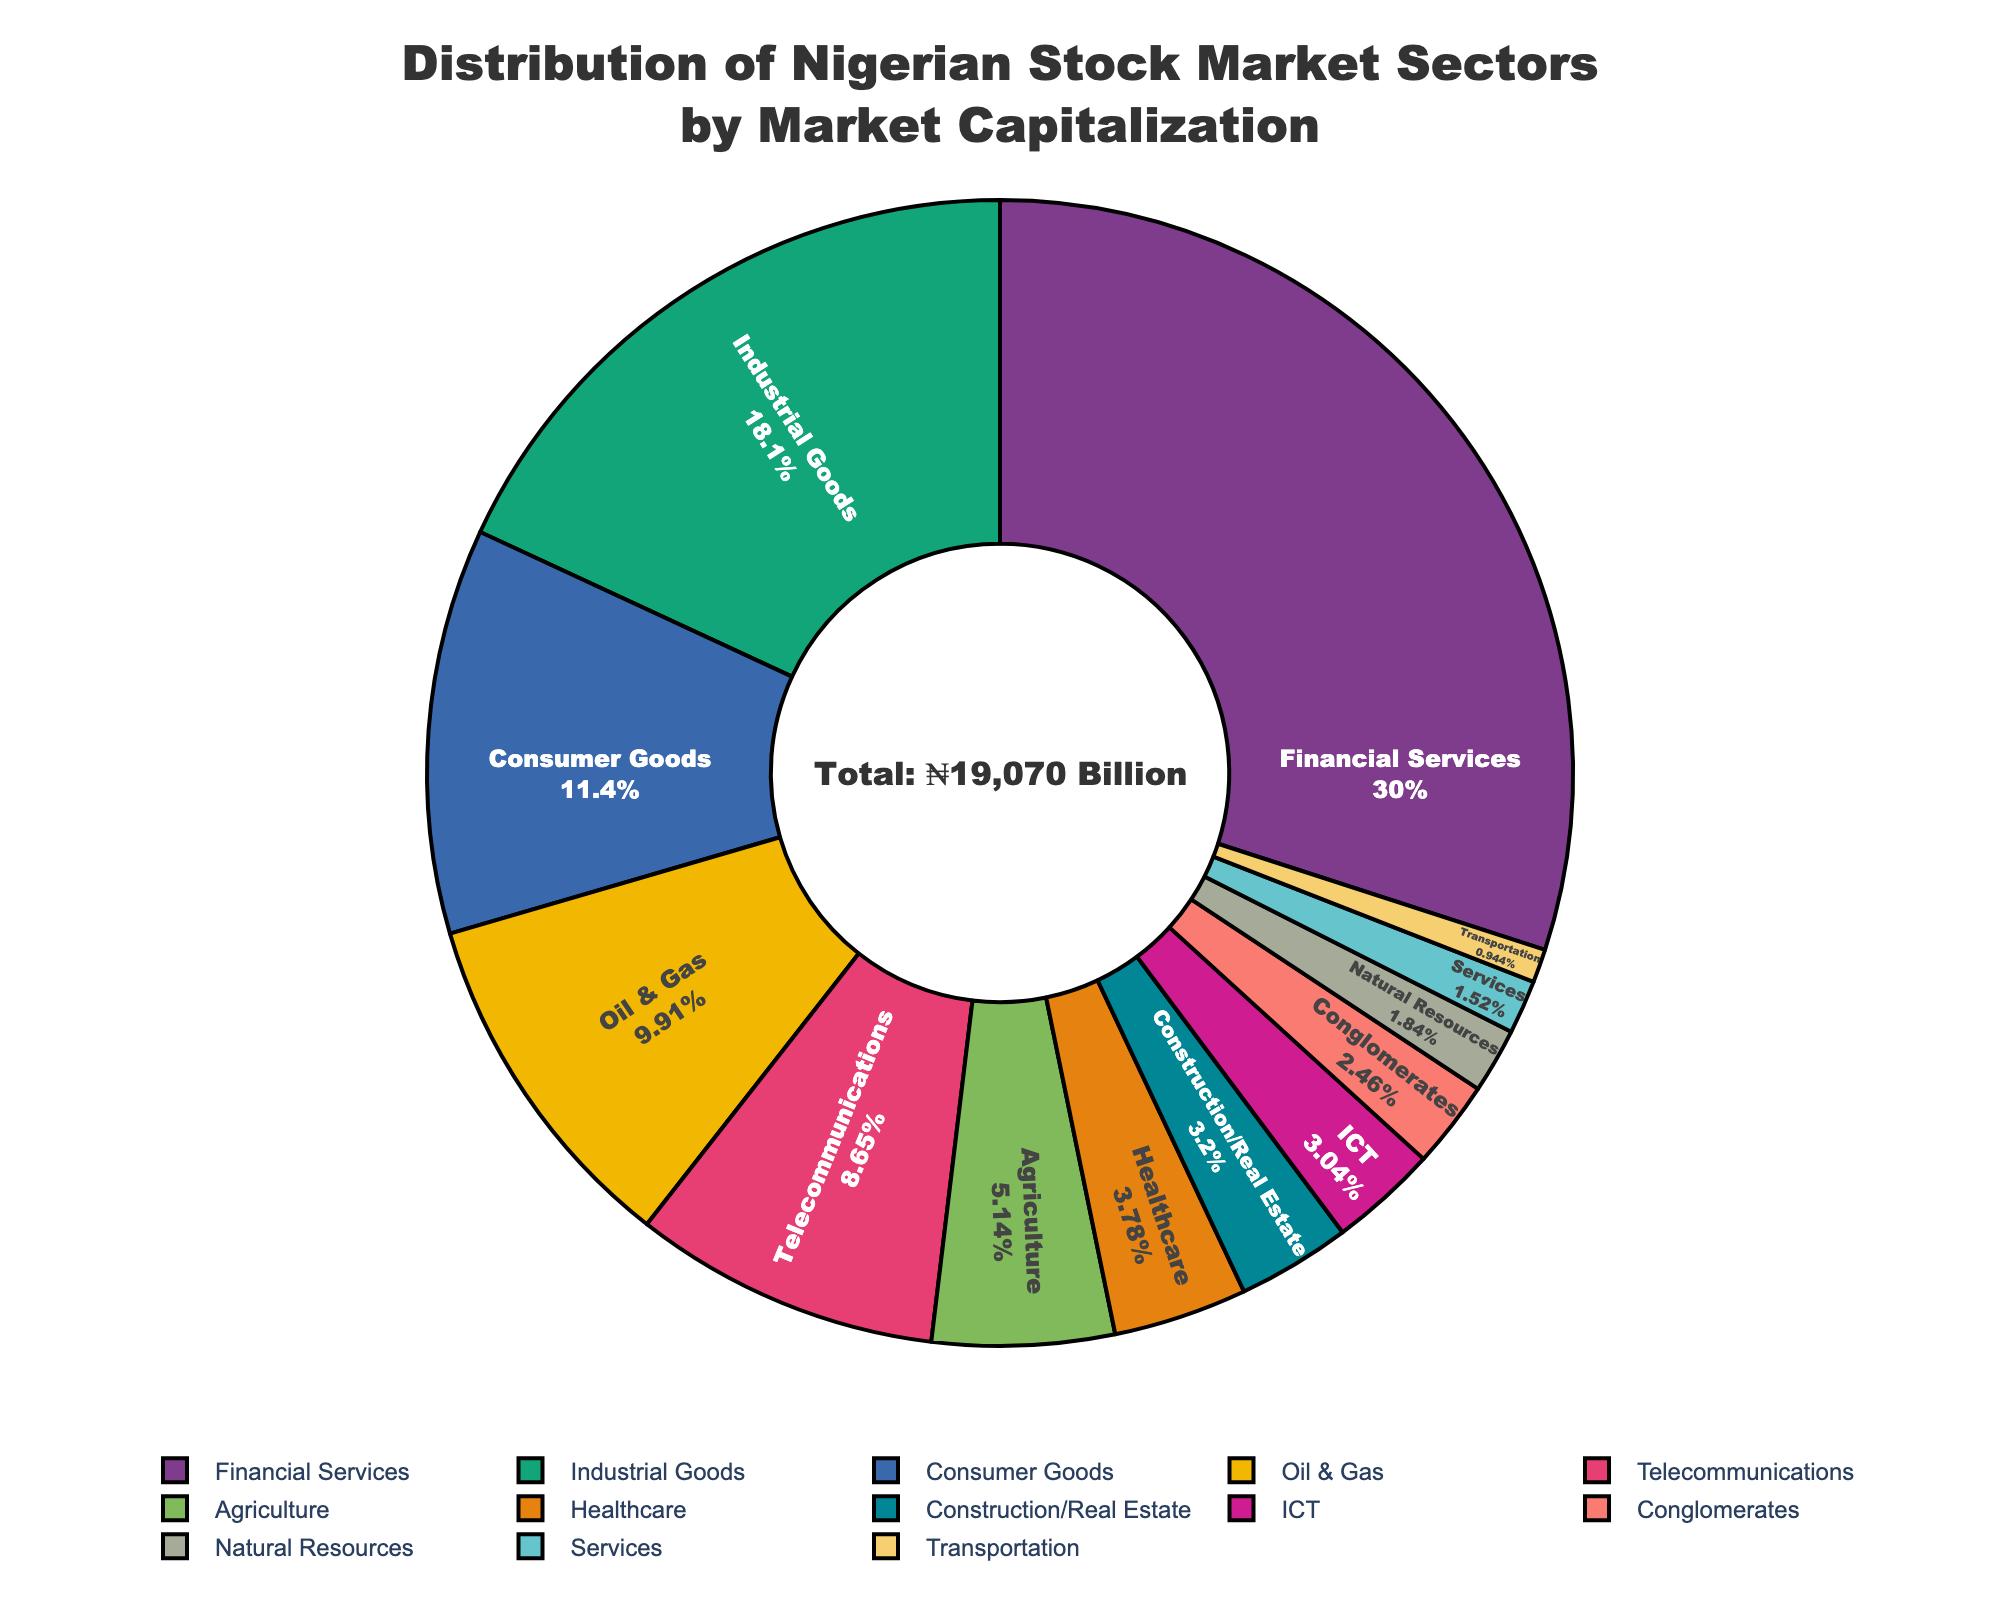What is the largest sector by market capitalization? The largest sector by market capitalization can be determined by identifying the sector with the highest value in the pie chart. The "Financial Services" sector is the largest, dominating a significant portion of the chart.
Answer: Financial Services Which two sectors combined hold the same market capitalization as the Industrial Goods sector? First, find the market capitalization of the Industrial Goods sector, which is 3450 billion Naira. Then, look for a combination of two sectors that sum up to this value. "Consumer Goods" (2180 billion Naira) and "Oil & Gas" (1890 billion Naira) together exceed Industrial Goods, but "Oil & Gas" alone isn't enough. Next, combine "Telecommunications" (1650 billion Naira) and "Agriculture" (980 billion Naira), adding up to 2630 billion Naira which is not enough either. Finally, combine "Telecommunications" (1650 billion Naira) and "Consumer Goods" (2180 billion Naira) which sum to 3830 billion Naira, close to 3450 billion Naira but still exceeds it. The best estimate with multiple trials isn't found as shown sectors can't match exactly. Hence, it's an approximate close-value exercise hint.
Answer: Consumer Goods and Telecommunications (approximate) What is the difference in market capitalization between the Healthcare and ICT sectors? The market capitalization of the Healthcare sector is 720 billion Naira, and the ICT sector is 580 billion Naira. The difference is calculated by subtracting the smaller from the larger value (720-580).
Answer: 140 billion Naira Which sector is represented by the smallest slice in the chart? To determine the smallest sector, we identify the slice with the smallest market capitalization. The "Transportation" sector is the smallest in terms of its area in the pie chart.
Answer: Transportation How much larger is the Financial Services sector compared to the Natural Resources sector? The market capitalization for Financial Services is 5720 billion Naira, and for Natural Resources, it is 350 billion Naira. Subtract the Natural Resources value from the Financial Services value (5720 - 350).
Answer: 5370 billion Naira 